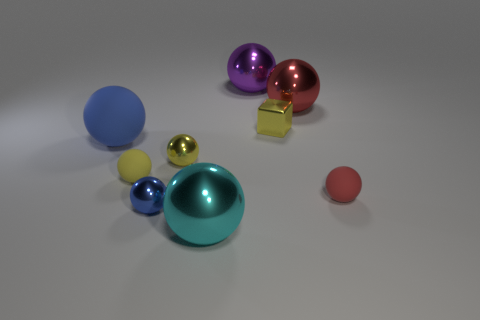What number of things are either yellow metallic things on the right side of the cyan thing or cyan things?
Offer a terse response. 2. How many other objects are the same material as the purple sphere?
Provide a succinct answer. 5. There is a tiny shiny thing that is the same color as the small metallic block; what is its shape?
Offer a terse response. Sphere. There is a red ball that is behind the big matte thing; what size is it?
Keep it short and to the point. Large. The small yellow thing that is the same material as the big blue object is what shape?
Make the answer very short. Sphere. Is the big cyan thing made of the same material as the yellow thing behind the big rubber ball?
Your answer should be compact. Yes. There is a tiny matte thing on the left side of the large cyan shiny sphere; is it the same shape as the large blue matte object?
Provide a short and direct response. Yes. There is another big cyan object that is the same shape as the large matte object; what material is it?
Give a very brief answer. Metal. Does the cyan thing have the same shape as the large thing on the left side of the tiny blue metallic ball?
Ensure brevity in your answer.  Yes. There is a metallic ball that is both in front of the large red ball and behind the red matte ball; what is its color?
Make the answer very short. Yellow. 